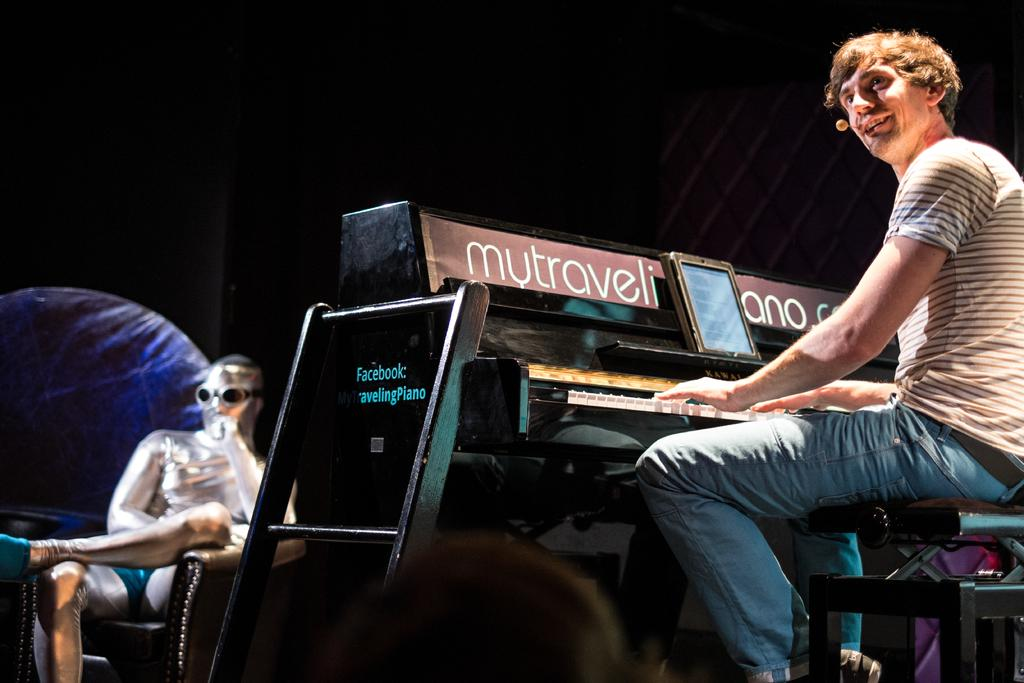What are the people in the image doing? The people in the image are playing a piano. Are there any other objects or people in the image? Yes, there is a man sitting on a chair in front of the piano players. What is the man wearing? The man is wearing goggles. How many apples are on the piano in the image? There are no apples present in the image. What type of dust can be seen on the man's hands in the image? There is no dust visible on the man's hands in the image, and the man's hands are not mentioned in the provided facts. 